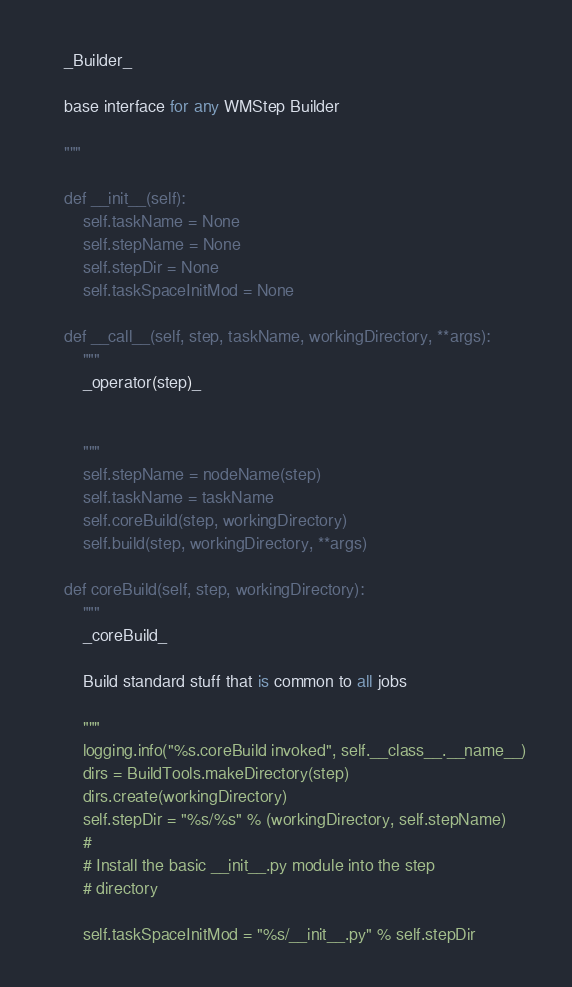<code> <loc_0><loc_0><loc_500><loc_500><_Python_>    _Builder_

    base interface for any WMStep Builder

    """

    def __init__(self):
        self.taskName = None
        self.stepName = None
        self.stepDir = None
        self.taskSpaceInitMod = None

    def __call__(self, step, taskName, workingDirectory, **args):
        """
        _operator(step)_


        """
        self.stepName = nodeName(step)
        self.taskName = taskName
        self.coreBuild(step, workingDirectory)
        self.build(step, workingDirectory, **args)

    def coreBuild(self, step, workingDirectory):
        """
        _coreBuild_

        Build standard stuff that is common to all jobs

        """
        logging.info("%s.coreBuild invoked", self.__class__.__name__)
        dirs = BuildTools.makeDirectory(step)
        dirs.create(workingDirectory)
        self.stepDir = "%s/%s" % (workingDirectory, self.stepName)
        #
        # Install the basic __init__.py module into the step
        # directory

        self.taskSpaceInitMod = "%s/__init__.py" % self.stepDir
</code> 